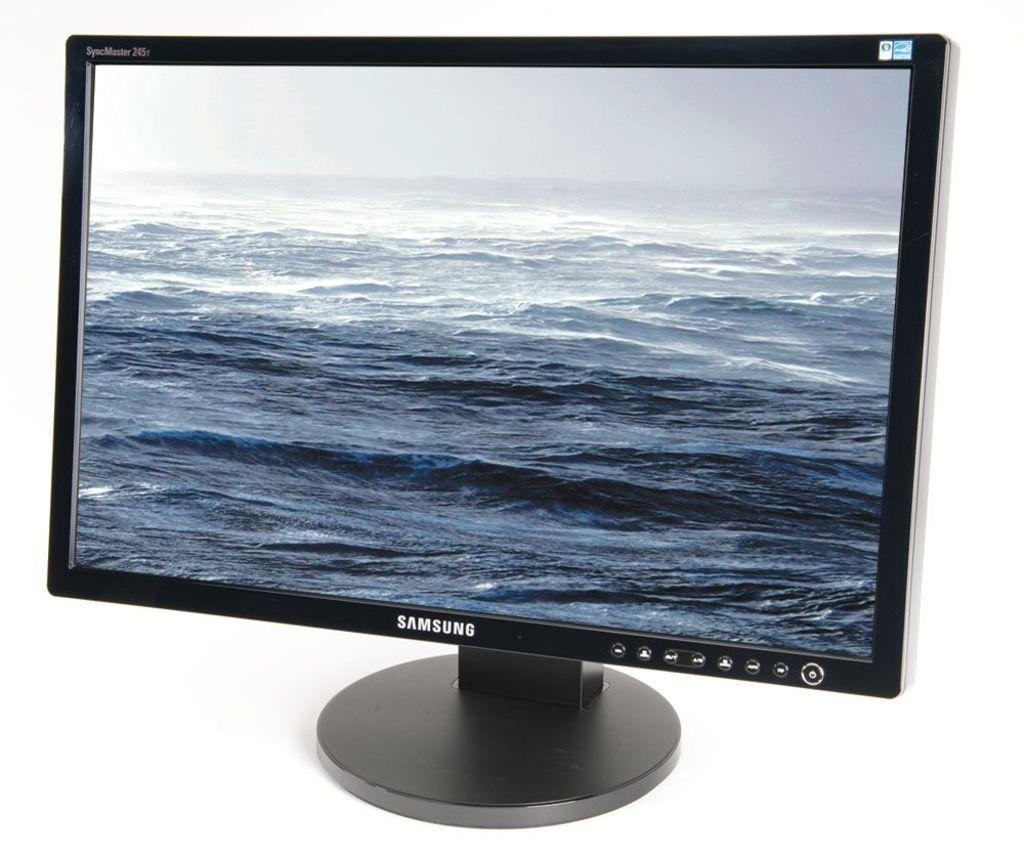<image>
Relay a brief, clear account of the picture shown. A blue ocean background on a Samsung monitor 